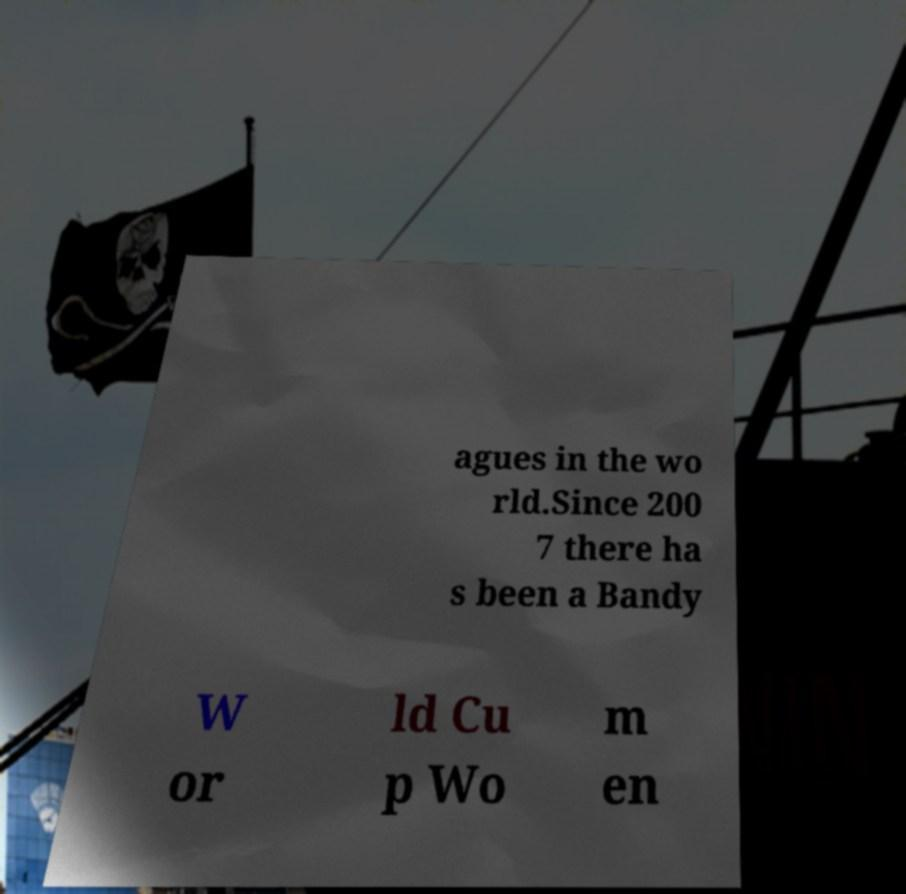I need the written content from this picture converted into text. Can you do that? agues in the wo rld.Since 200 7 there ha s been a Bandy W or ld Cu p Wo m en 